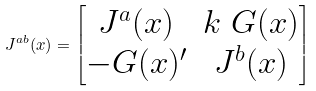<formula> <loc_0><loc_0><loc_500><loc_500>J ^ { a b } ( x ) = \begin{bmatrix} J ^ { a } ( x ) & k \ G ( x ) \\ - G ( x ) ^ { \prime } & J ^ { b } ( x ) \end{bmatrix}</formula> 